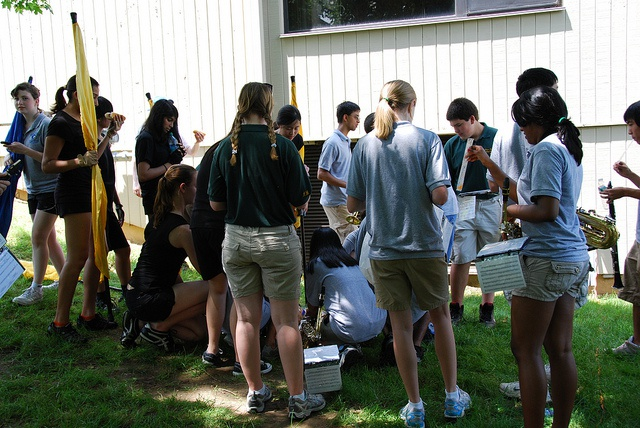Describe the objects in this image and their specific colors. I can see people in white, black, gray, and maroon tones, people in white, black, gray, blue, and darkblue tones, people in white, black, gray, and blue tones, people in white, black, and gray tones, and people in white, black, maroon, and gray tones in this image. 